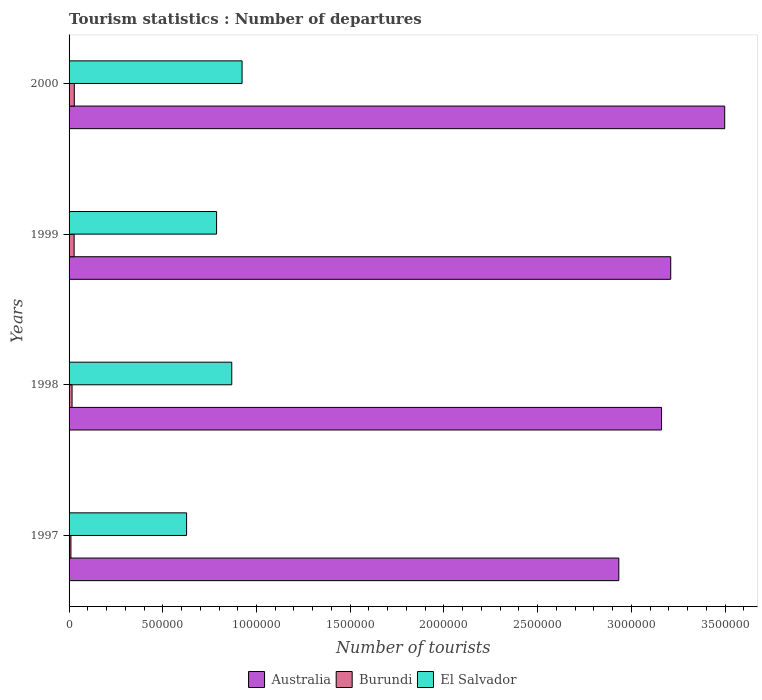How many different coloured bars are there?
Offer a terse response. 3. Are the number of bars per tick equal to the number of legend labels?
Keep it short and to the point. Yes. How many bars are there on the 4th tick from the top?
Keep it short and to the point. 3. How many bars are there on the 3rd tick from the bottom?
Keep it short and to the point. 3. In how many cases, is the number of bars for a given year not equal to the number of legend labels?
Provide a short and direct response. 0. What is the number of tourist departures in El Salvador in 2000?
Your response must be concise. 9.23e+05. Across all years, what is the maximum number of tourist departures in Australia?
Offer a very short reply. 3.50e+06. In which year was the number of tourist departures in Australia minimum?
Ensure brevity in your answer.  1997. What is the total number of tourist departures in El Salvador in the graph?
Offer a very short reply. 3.20e+06. What is the difference between the number of tourist departures in El Salvador in 1997 and that in 2000?
Provide a succinct answer. -2.96e+05. What is the difference between the number of tourist departures in Burundi in 1997 and the number of tourist departures in Australia in 1998?
Give a very brief answer. -3.15e+06. What is the average number of tourist departures in Burundi per year?
Your answer should be very brief. 2.02e+04. In the year 2000, what is the difference between the number of tourist departures in Australia and number of tourist departures in Burundi?
Provide a succinct answer. 3.47e+06. What is the ratio of the number of tourist departures in Australia in 1998 to that in 2000?
Your answer should be very brief. 0.9. Is the difference between the number of tourist departures in Australia in 1998 and 2000 greater than the difference between the number of tourist departures in Burundi in 1998 and 2000?
Ensure brevity in your answer.  No. What is the difference between the highest and the second highest number of tourist departures in El Salvador?
Your answer should be very brief. 5.50e+04. What is the difference between the highest and the lowest number of tourist departures in Australia?
Your response must be concise. 5.65e+05. Is the sum of the number of tourist departures in Australia in 1998 and 1999 greater than the maximum number of tourist departures in Burundi across all years?
Your answer should be very brief. Yes. What does the 1st bar from the top in 2000 represents?
Your response must be concise. El Salvador. What does the 1st bar from the bottom in 1997 represents?
Make the answer very short. Australia. Does the graph contain any zero values?
Ensure brevity in your answer.  No. Does the graph contain grids?
Your answer should be very brief. No. Where does the legend appear in the graph?
Your response must be concise. Bottom center. How many legend labels are there?
Make the answer very short. 3. How are the legend labels stacked?
Keep it short and to the point. Horizontal. What is the title of the graph?
Your answer should be compact. Tourism statistics : Number of departures. Does "Seychelles" appear as one of the legend labels in the graph?
Make the answer very short. No. What is the label or title of the X-axis?
Make the answer very short. Number of tourists. What is the Number of tourists of Australia in 1997?
Provide a succinct answer. 2.93e+06. What is the Number of tourists of El Salvador in 1997?
Offer a very short reply. 6.27e+05. What is the Number of tourists in Australia in 1998?
Provide a short and direct response. 3.16e+06. What is the Number of tourists in Burundi in 1998?
Provide a short and direct response. 1.60e+04. What is the Number of tourists in El Salvador in 1998?
Provide a succinct answer. 8.68e+05. What is the Number of tourists of Australia in 1999?
Offer a very short reply. 3.21e+06. What is the Number of tourists of Burundi in 1999?
Offer a very short reply. 2.70e+04. What is the Number of tourists in El Salvador in 1999?
Offer a very short reply. 7.87e+05. What is the Number of tourists in Australia in 2000?
Provide a short and direct response. 3.50e+06. What is the Number of tourists of Burundi in 2000?
Provide a short and direct response. 2.80e+04. What is the Number of tourists in El Salvador in 2000?
Provide a succinct answer. 9.23e+05. Across all years, what is the maximum Number of tourists of Australia?
Your answer should be compact. 3.50e+06. Across all years, what is the maximum Number of tourists of Burundi?
Give a very brief answer. 2.80e+04. Across all years, what is the maximum Number of tourists in El Salvador?
Offer a terse response. 9.23e+05. Across all years, what is the minimum Number of tourists in Australia?
Give a very brief answer. 2.93e+06. Across all years, what is the minimum Number of tourists of El Salvador?
Your answer should be compact. 6.27e+05. What is the total Number of tourists in Australia in the graph?
Offer a terse response. 1.28e+07. What is the total Number of tourists in Burundi in the graph?
Offer a very short reply. 8.10e+04. What is the total Number of tourists in El Salvador in the graph?
Ensure brevity in your answer.  3.20e+06. What is the difference between the Number of tourists in Australia in 1997 and that in 1998?
Give a very brief answer. -2.28e+05. What is the difference between the Number of tourists of Burundi in 1997 and that in 1998?
Give a very brief answer. -6000. What is the difference between the Number of tourists in El Salvador in 1997 and that in 1998?
Provide a short and direct response. -2.41e+05. What is the difference between the Number of tourists of Australia in 1997 and that in 1999?
Your response must be concise. -2.77e+05. What is the difference between the Number of tourists of Burundi in 1997 and that in 1999?
Offer a terse response. -1.70e+04. What is the difference between the Number of tourists in Australia in 1997 and that in 2000?
Offer a terse response. -5.65e+05. What is the difference between the Number of tourists of Burundi in 1997 and that in 2000?
Make the answer very short. -1.80e+04. What is the difference between the Number of tourists in El Salvador in 1997 and that in 2000?
Ensure brevity in your answer.  -2.96e+05. What is the difference between the Number of tourists in Australia in 1998 and that in 1999?
Keep it short and to the point. -4.90e+04. What is the difference between the Number of tourists of Burundi in 1998 and that in 1999?
Offer a very short reply. -1.10e+04. What is the difference between the Number of tourists of El Salvador in 1998 and that in 1999?
Keep it short and to the point. 8.10e+04. What is the difference between the Number of tourists in Australia in 1998 and that in 2000?
Your response must be concise. -3.37e+05. What is the difference between the Number of tourists of Burundi in 1998 and that in 2000?
Offer a terse response. -1.20e+04. What is the difference between the Number of tourists in El Salvador in 1998 and that in 2000?
Provide a succinct answer. -5.50e+04. What is the difference between the Number of tourists in Australia in 1999 and that in 2000?
Give a very brief answer. -2.88e+05. What is the difference between the Number of tourists of Burundi in 1999 and that in 2000?
Your answer should be very brief. -1000. What is the difference between the Number of tourists of El Salvador in 1999 and that in 2000?
Keep it short and to the point. -1.36e+05. What is the difference between the Number of tourists of Australia in 1997 and the Number of tourists of Burundi in 1998?
Your response must be concise. 2.92e+06. What is the difference between the Number of tourists in Australia in 1997 and the Number of tourists in El Salvador in 1998?
Offer a terse response. 2.06e+06. What is the difference between the Number of tourists in Burundi in 1997 and the Number of tourists in El Salvador in 1998?
Provide a succinct answer. -8.58e+05. What is the difference between the Number of tourists of Australia in 1997 and the Number of tourists of Burundi in 1999?
Offer a very short reply. 2.91e+06. What is the difference between the Number of tourists of Australia in 1997 and the Number of tourists of El Salvador in 1999?
Ensure brevity in your answer.  2.15e+06. What is the difference between the Number of tourists of Burundi in 1997 and the Number of tourists of El Salvador in 1999?
Your answer should be compact. -7.77e+05. What is the difference between the Number of tourists of Australia in 1997 and the Number of tourists of Burundi in 2000?
Ensure brevity in your answer.  2.90e+06. What is the difference between the Number of tourists of Australia in 1997 and the Number of tourists of El Salvador in 2000?
Keep it short and to the point. 2.01e+06. What is the difference between the Number of tourists of Burundi in 1997 and the Number of tourists of El Salvador in 2000?
Keep it short and to the point. -9.13e+05. What is the difference between the Number of tourists in Australia in 1998 and the Number of tourists in Burundi in 1999?
Ensure brevity in your answer.  3.13e+06. What is the difference between the Number of tourists in Australia in 1998 and the Number of tourists in El Salvador in 1999?
Offer a terse response. 2.37e+06. What is the difference between the Number of tourists of Burundi in 1998 and the Number of tourists of El Salvador in 1999?
Your answer should be very brief. -7.71e+05. What is the difference between the Number of tourists in Australia in 1998 and the Number of tourists in Burundi in 2000?
Your answer should be compact. 3.13e+06. What is the difference between the Number of tourists of Australia in 1998 and the Number of tourists of El Salvador in 2000?
Provide a short and direct response. 2.24e+06. What is the difference between the Number of tourists of Burundi in 1998 and the Number of tourists of El Salvador in 2000?
Offer a terse response. -9.07e+05. What is the difference between the Number of tourists of Australia in 1999 and the Number of tourists of Burundi in 2000?
Offer a terse response. 3.18e+06. What is the difference between the Number of tourists in Australia in 1999 and the Number of tourists in El Salvador in 2000?
Your answer should be very brief. 2.29e+06. What is the difference between the Number of tourists of Burundi in 1999 and the Number of tourists of El Salvador in 2000?
Ensure brevity in your answer.  -8.96e+05. What is the average Number of tourists in Australia per year?
Make the answer very short. 3.20e+06. What is the average Number of tourists in Burundi per year?
Your answer should be very brief. 2.02e+04. What is the average Number of tourists in El Salvador per year?
Offer a terse response. 8.01e+05. In the year 1997, what is the difference between the Number of tourists in Australia and Number of tourists in Burundi?
Provide a succinct answer. 2.92e+06. In the year 1997, what is the difference between the Number of tourists of Australia and Number of tourists of El Salvador?
Your answer should be very brief. 2.31e+06. In the year 1997, what is the difference between the Number of tourists in Burundi and Number of tourists in El Salvador?
Ensure brevity in your answer.  -6.17e+05. In the year 1998, what is the difference between the Number of tourists in Australia and Number of tourists in Burundi?
Provide a short and direct response. 3.14e+06. In the year 1998, what is the difference between the Number of tourists in Australia and Number of tourists in El Salvador?
Provide a succinct answer. 2.29e+06. In the year 1998, what is the difference between the Number of tourists in Burundi and Number of tourists in El Salvador?
Your answer should be compact. -8.52e+05. In the year 1999, what is the difference between the Number of tourists in Australia and Number of tourists in Burundi?
Ensure brevity in your answer.  3.18e+06. In the year 1999, what is the difference between the Number of tourists in Australia and Number of tourists in El Salvador?
Your response must be concise. 2.42e+06. In the year 1999, what is the difference between the Number of tourists in Burundi and Number of tourists in El Salvador?
Your answer should be compact. -7.60e+05. In the year 2000, what is the difference between the Number of tourists of Australia and Number of tourists of Burundi?
Provide a succinct answer. 3.47e+06. In the year 2000, what is the difference between the Number of tourists of Australia and Number of tourists of El Salvador?
Provide a succinct answer. 2.58e+06. In the year 2000, what is the difference between the Number of tourists of Burundi and Number of tourists of El Salvador?
Your answer should be very brief. -8.95e+05. What is the ratio of the Number of tourists of Australia in 1997 to that in 1998?
Provide a succinct answer. 0.93. What is the ratio of the Number of tourists in Burundi in 1997 to that in 1998?
Offer a terse response. 0.62. What is the ratio of the Number of tourists in El Salvador in 1997 to that in 1998?
Your answer should be compact. 0.72. What is the ratio of the Number of tourists of Australia in 1997 to that in 1999?
Ensure brevity in your answer.  0.91. What is the ratio of the Number of tourists in Burundi in 1997 to that in 1999?
Provide a succinct answer. 0.37. What is the ratio of the Number of tourists of El Salvador in 1997 to that in 1999?
Keep it short and to the point. 0.8. What is the ratio of the Number of tourists in Australia in 1997 to that in 2000?
Your answer should be compact. 0.84. What is the ratio of the Number of tourists of Burundi in 1997 to that in 2000?
Provide a succinct answer. 0.36. What is the ratio of the Number of tourists in El Salvador in 1997 to that in 2000?
Offer a terse response. 0.68. What is the ratio of the Number of tourists in Australia in 1998 to that in 1999?
Provide a short and direct response. 0.98. What is the ratio of the Number of tourists in Burundi in 1998 to that in 1999?
Your response must be concise. 0.59. What is the ratio of the Number of tourists of El Salvador in 1998 to that in 1999?
Provide a short and direct response. 1.1. What is the ratio of the Number of tourists of Australia in 1998 to that in 2000?
Your answer should be compact. 0.9. What is the ratio of the Number of tourists in El Salvador in 1998 to that in 2000?
Provide a short and direct response. 0.94. What is the ratio of the Number of tourists of Australia in 1999 to that in 2000?
Your response must be concise. 0.92. What is the ratio of the Number of tourists of Burundi in 1999 to that in 2000?
Provide a short and direct response. 0.96. What is the ratio of the Number of tourists of El Salvador in 1999 to that in 2000?
Make the answer very short. 0.85. What is the difference between the highest and the second highest Number of tourists in Australia?
Ensure brevity in your answer.  2.88e+05. What is the difference between the highest and the second highest Number of tourists of Burundi?
Provide a short and direct response. 1000. What is the difference between the highest and the second highest Number of tourists in El Salvador?
Ensure brevity in your answer.  5.50e+04. What is the difference between the highest and the lowest Number of tourists of Australia?
Your answer should be very brief. 5.65e+05. What is the difference between the highest and the lowest Number of tourists in Burundi?
Your answer should be very brief. 1.80e+04. What is the difference between the highest and the lowest Number of tourists in El Salvador?
Your response must be concise. 2.96e+05. 